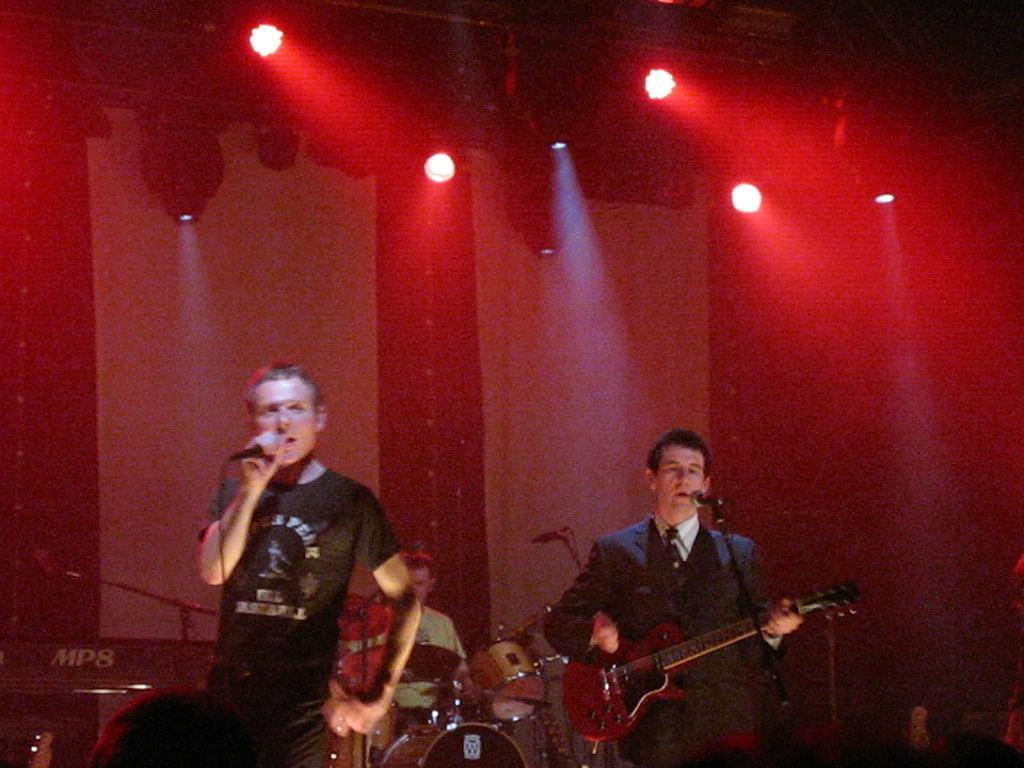Describe this image in one or two sentences. In this picture there is a man who is singing. There is also another man who is playing a guitar and singing. At the background there is a man who is sitting and playing the musical instrument. 